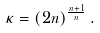Convert formula to latex. <formula><loc_0><loc_0><loc_500><loc_500>\kappa = ( 2 n ) ^ { \frac { n + 1 } { n } } \, .</formula> 